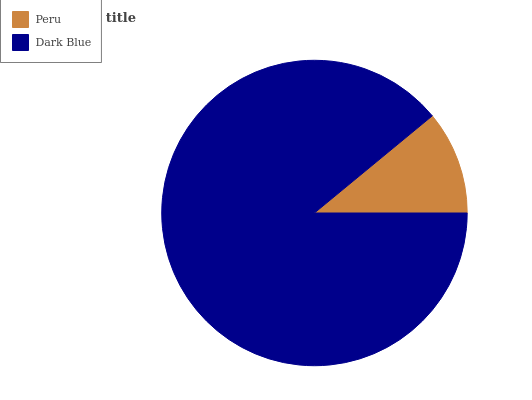Is Peru the minimum?
Answer yes or no. Yes. Is Dark Blue the maximum?
Answer yes or no. Yes. Is Dark Blue the minimum?
Answer yes or no. No. Is Dark Blue greater than Peru?
Answer yes or no. Yes. Is Peru less than Dark Blue?
Answer yes or no. Yes. Is Peru greater than Dark Blue?
Answer yes or no. No. Is Dark Blue less than Peru?
Answer yes or no. No. Is Dark Blue the high median?
Answer yes or no. Yes. Is Peru the low median?
Answer yes or no. Yes. Is Peru the high median?
Answer yes or no. No. Is Dark Blue the low median?
Answer yes or no. No. 